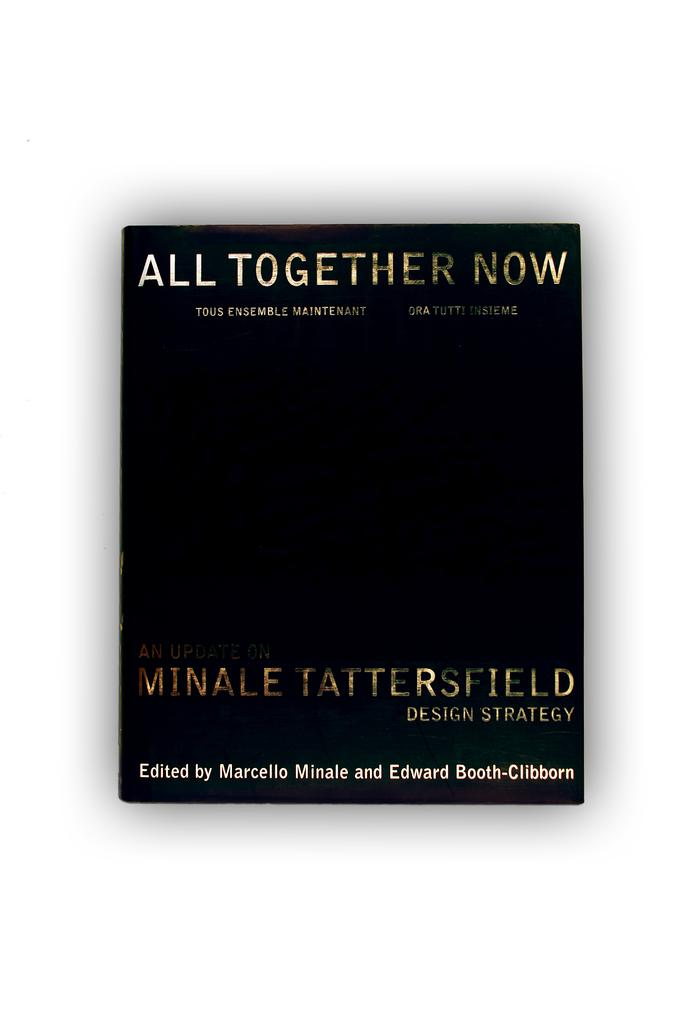Provide a one-sentence caption for the provided image. Here we have a black book with a title of "All Together Now' written by Minale Tattersfield Design Strategy. 